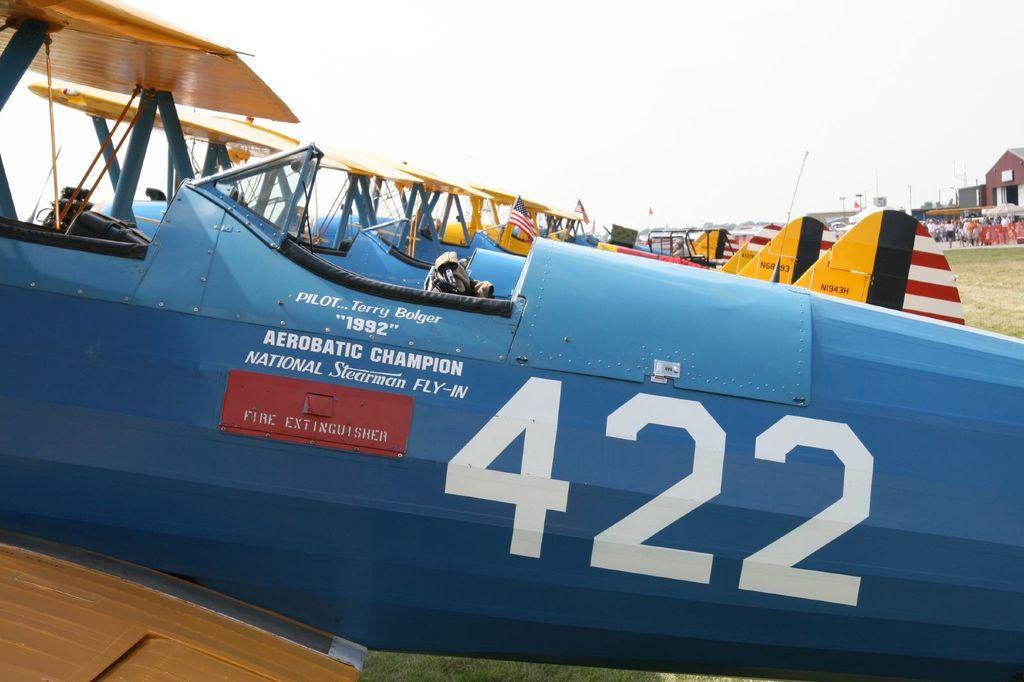Provide a one-sentence caption for the provided image. A blue aeroplane fuselage with the number 422 on it. 